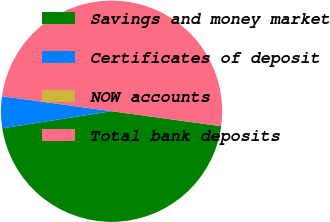Convert chart to OTSL. <chart><loc_0><loc_0><loc_500><loc_500><pie_chart><fcel>Savings and money market<fcel>Certificates of deposit<fcel>NOW accounts<fcel>Total bank deposits<nl><fcel>45.36%<fcel>4.64%<fcel>0.01%<fcel>49.99%<nl></chart> 